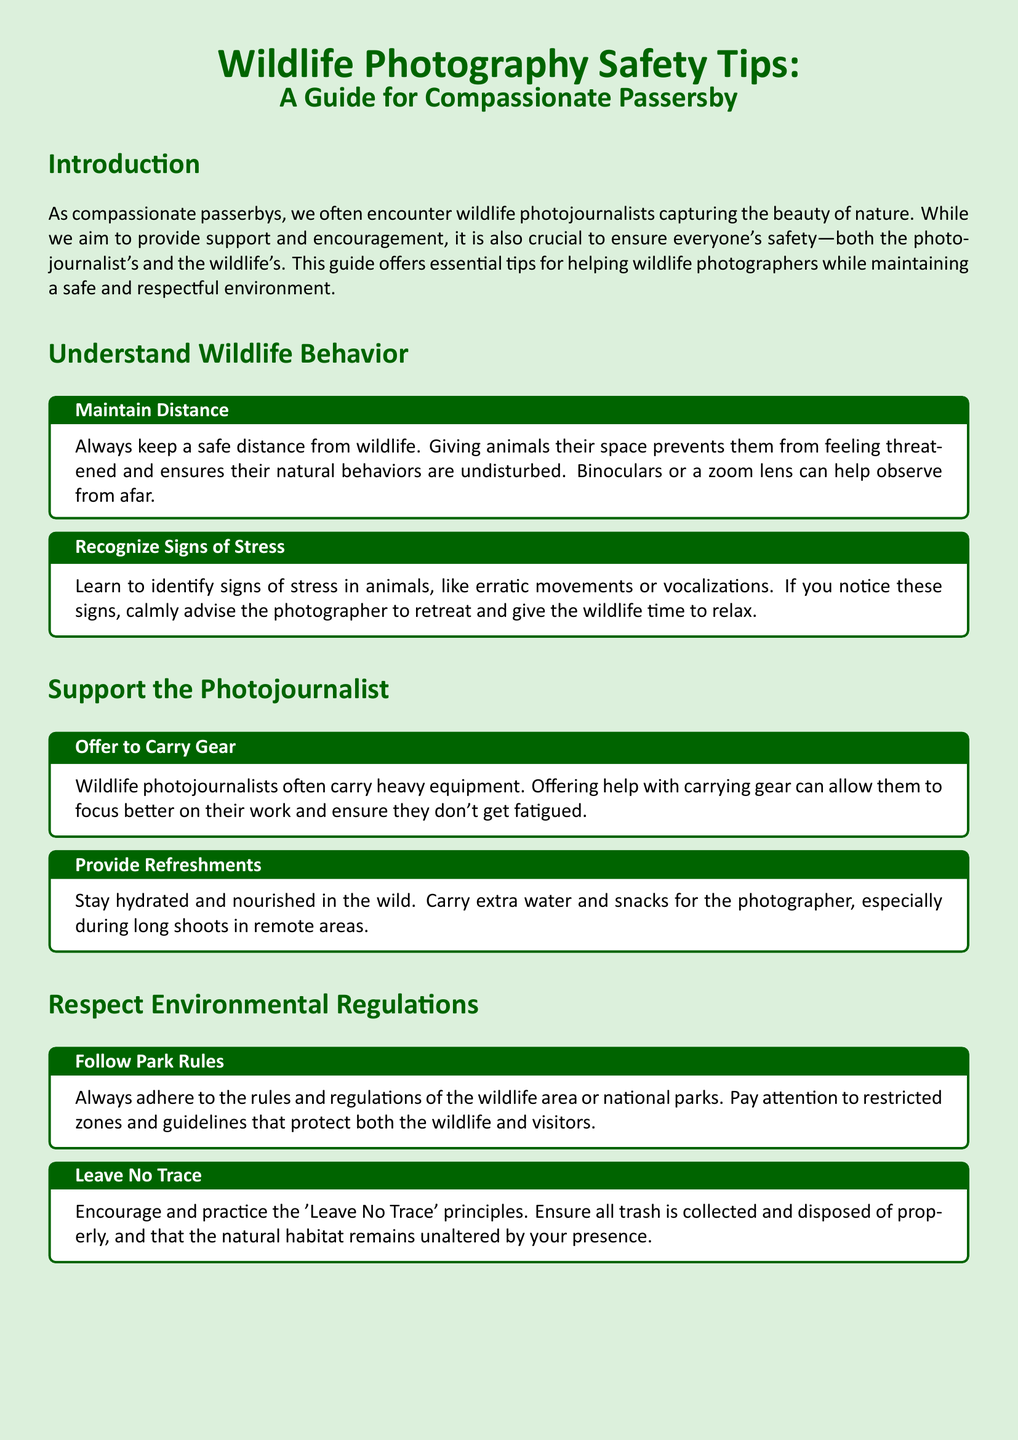What is the title of the guide? The title of the guide is the main heading presented at the top of the document.
Answer: Wildlife Photography Safety Tips: A Guide for Compassionate Passersby What is the purpose of this guide? The purpose of the guide is stated in the introduction, outlining the aims for both support and safety.
Answer: To help wildlife photographers while ensuring safety What should you offer to a wildlife photojournalist? This information is found in the section that discusses supporting the photographer.
Answer: To Carry Gear What is a sign of stress in animals? This can be found in the tips on understanding wildlife behavior.
Answer: Erratic movements Which principle encourages environmental stewardship? The document mentions this principle in the section on respecting environmental regulations.
Answer: Leave No Trace What is mentioned as a way to help the photographer during long shoots? This information is stated in the section offering support to the photojournalist.
Answer: Provide Refreshments What is a recommended action if you notice signs of animal stress? This is described in the tips for understanding wildlife behavior.
Answer: Advise the photographer to retreat How should you approach park regulations? The document describes how to interact with park rules in a specific section.
Answer: Follow Park Rules 